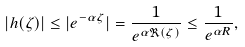Convert formula to latex. <formula><loc_0><loc_0><loc_500><loc_500>| h ( \zeta ) | \leq | e ^ { - \alpha \zeta } | = \frac { 1 } { e ^ { \alpha \Re ( \zeta ) } } \leq \frac { 1 } { e ^ { \alpha R } } ,</formula> 